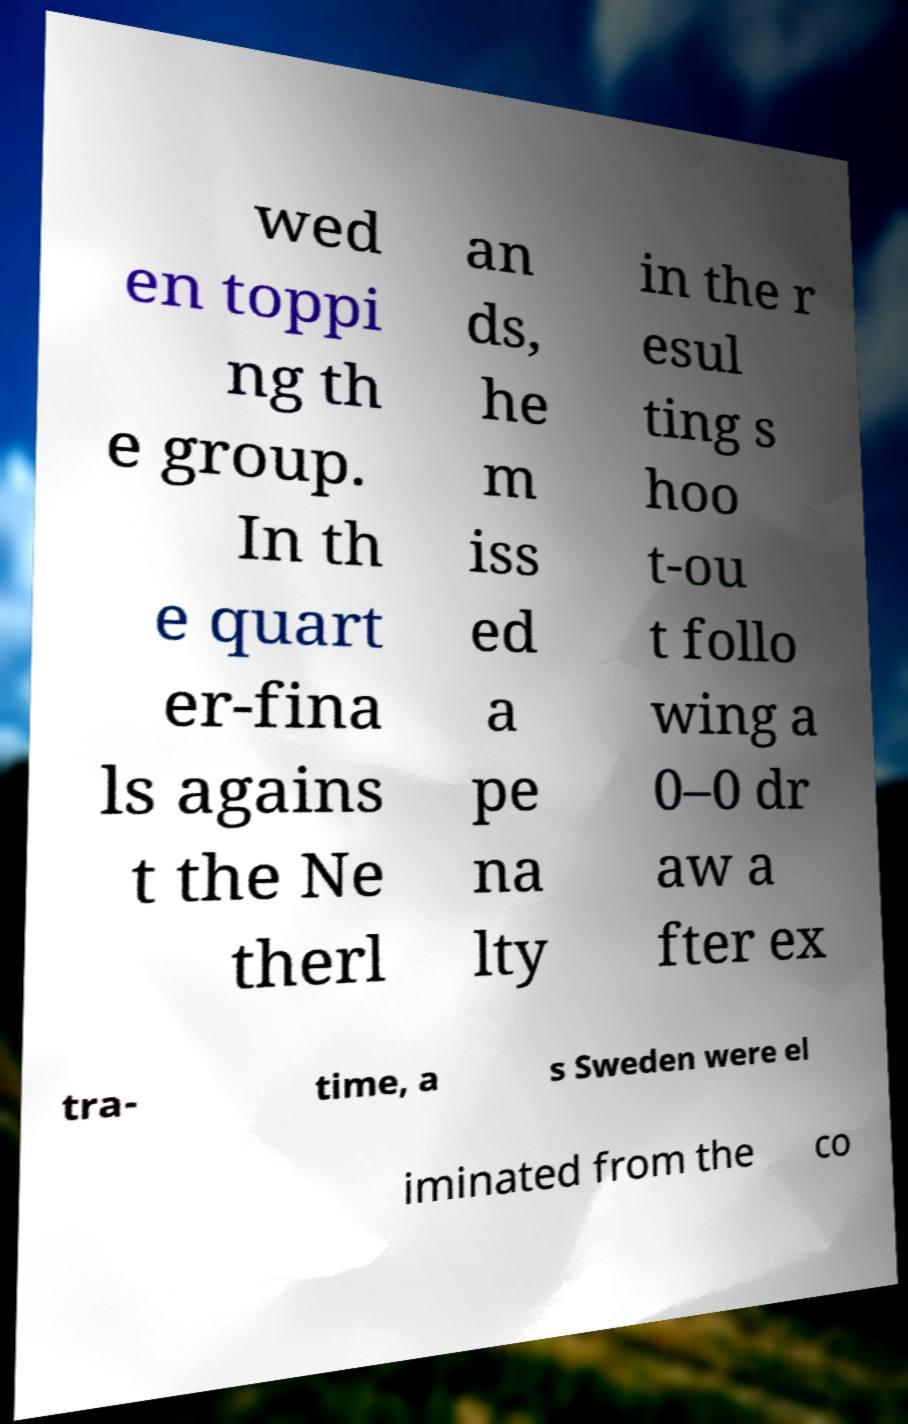What messages or text are displayed in this image? I need them in a readable, typed format. wed en toppi ng th e group. In th e quart er-fina ls agains t the Ne therl an ds, he m iss ed a pe na lty in the r esul ting s hoo t-ou t follo wing a 0–0 dr aw a fter ex tra- time, a s Sweden were el iminated from the co 